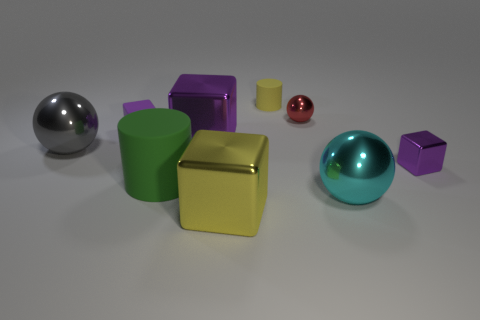What shape is the big thing that is the same color as the small rubber cylinder?
Provide a short and direct response. Cube. Is the color of the small rubber cube the same as the tiny metallic block?
Your answer should be compact. Yes. How many metal things are the same color as the small matte cylinder?
Ensure brevity in your answer.  1. There is a purple shiny object that is the same size as the yellow matte object; what shape is it?
Your response must be concise. Cube. Are there any metal cylinders that have the same size as the green rubber cylinder?
Make the answer very short. No. There is a cyan ball that is the same size as the yellow shiny block; what is it made of?
Your answer should be very brief. Metal. There is a metal block that is right of the small matte object that is to the right of the small purple rubber thing; what size is it?
Offer a terse response. Small. Is the size of the cylinder that is behind the gray shiny thing the same as the tiny rubber cube?
Keep it short and to the point. Yes. Are there more matte cylinders on the right side of the big green thing than small purple blocks that are in front of the small purple shiny object?
Ensure brevity in your answer.  Yes. The small object that is to the right of the yellow rubber object and in front of the small red metal ball has what shape?
Provide a succinct answer. Cube. 